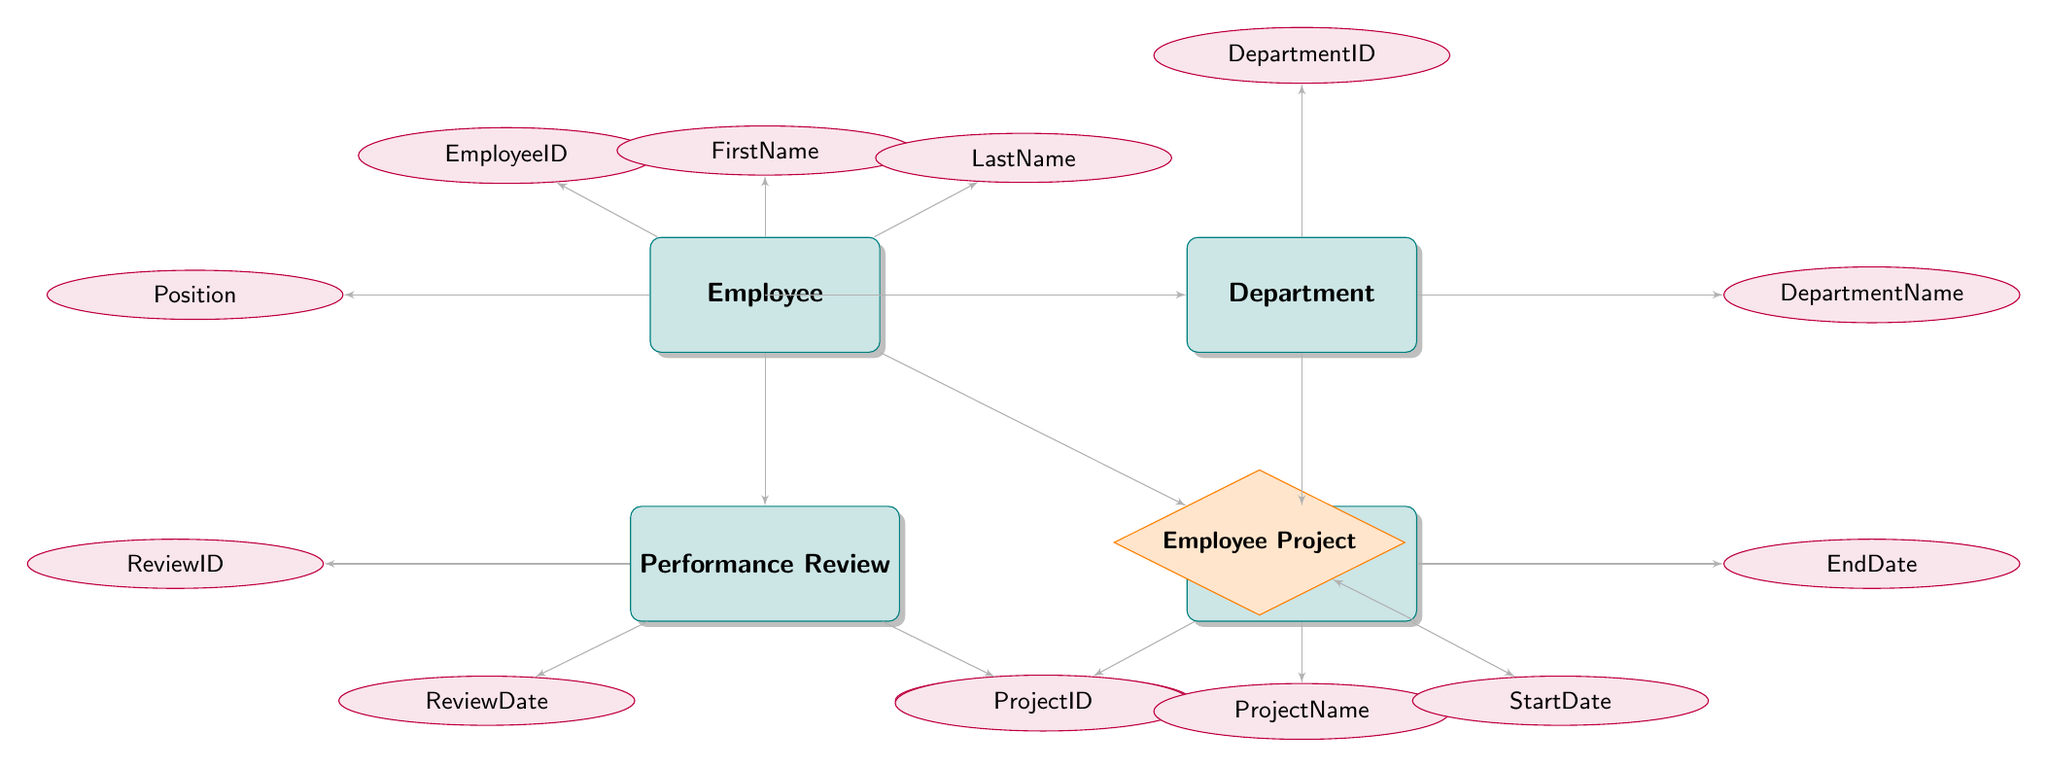What is the primary key of the Employee entity? The primary key is indicated in the diagram for the Employee entity as EmployeeID, which uniquely identifies each employee record.
Answer: EmployeeID How many attributes does the Performance Review entity have? By examining the attributes listed for the Performance Review entity, there are a total of three distinct attributes: ReviewID, ReviewDate, and Score.
Answer: Three What does the Employee Project relationship connect? The Employee Project relationship connects the Employee and Project entities, as noted by the lines that link these two entities in the diagram.
Answer: Employee and Project Which entity is linked to the Department entity? The diagram shows that the Project entity is linked to the Department entity through a foreign key relationship that references DepartmentID in the Department table.
Answer: Project How many attributes does the Project entity have? The Project entity contains four attributes: ProjectID, ProjectName, StartDate, and EndDate.
Answer: Four What is the role of EmployeeID in the Performance Review entity? The EmployeeID attribute in the Performance Review entity serves as a foreign key, linking to the Employee entity to associate reviews with specific employees based on their EmployeeID.
Answer: Foreign key Can an employee work on multiple projects? The presence of the Employee Project entity, which connects multiple employees with various projects, indicates that yes, an employee can indeed work on multiple projects.
Answer: Yes Which department does the attribute DepartmentName belong to? The DepartmentName attribute is part of the Department entity, as explicitly indicated in the attributes listed under the Department entity in the diagram.
Answer: Department What is the relationship type between Employee and Performance Review? The relationship between Employee and Performance Review is a one-to-many relationship, as each employee can have multiple performance reviews, but each review belongs to only one employee.
Answer: One-to-many 